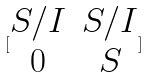Convert formula to latex. <formula><loc_0><loc_0><loc_500><loc_500>[ \begin{matrix} S / I & S / I \\ 0 & S \end{matrix} ]</formula> 